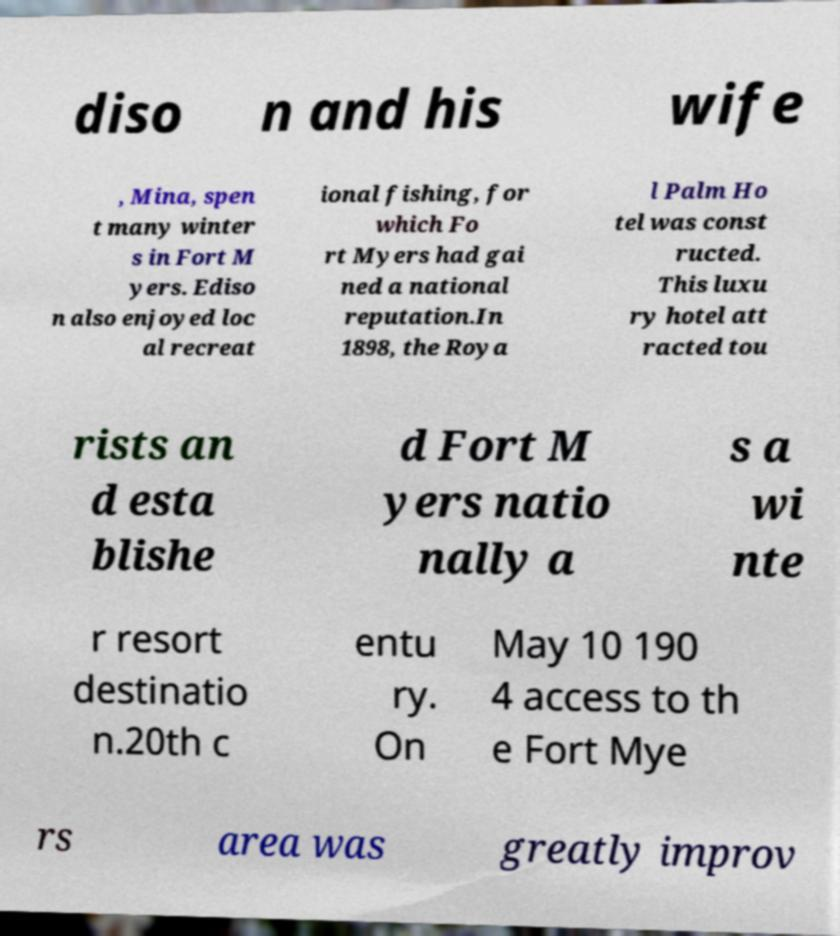Could you extract and type out the text from this image? diso n and his wife , Mina, spen t many winter s in Fort M yers. Ediso n also enjoyed loc al recreat ional fishing, for which Fo rt Myers had gai ned a national reputation.In 1898, the Roya l Palm Ho tel was const ructed. This luxu ry hotel att racted tou rists an d esta blishe d Fort M yers natio nally a s a wi nte r resort destinatio n.20th c entu ry. On May 10 190 4 access to th e Fort Mye rs area was greatly improv 